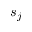Convert formula to latex. <formula><loc_0><loc_0><loc_500><loc_500>s _ { j }</formula> 